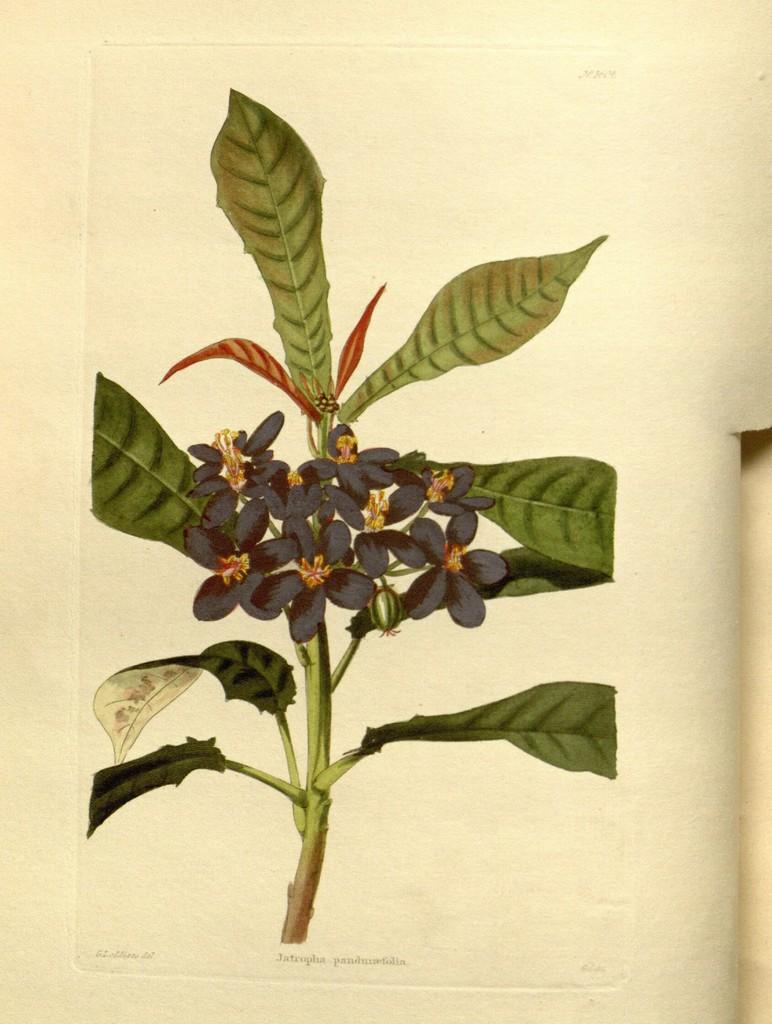What is the main subject of the image? The main subject of the image is a paper. What is depicted on the paper? There is a plant depicted on the paper. Is there any text on the paper? Yes, there is text written at the bottom of the paper. What type of payment is being made in the image? There is no payment being made in the image; it only features a paper with a plant and text. What kind of office furniture is visible in the image? There is no office furniture present in the image; it only features a paper with a plant and text. 